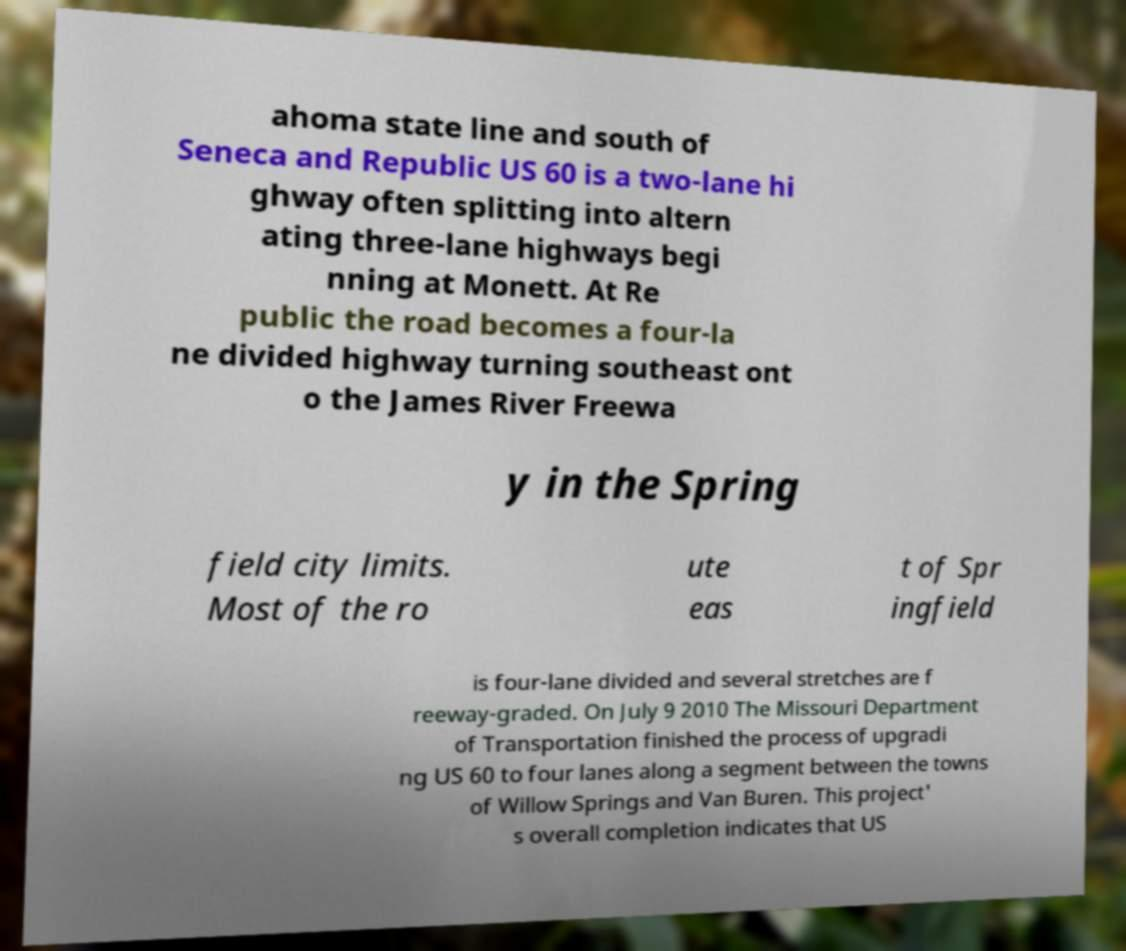There's text embedded in this image that I need extracted. Can you transcribe it verbatim? ahoma state line and south of Seneca and Republic US 60 is a two-lane hi ghway often splitting into altern ating three-lane highways begi nning at Monett. At Re public the road becomes a four-la ne divided highway turning southeast ont o the James River Freewa y in the Spring field city limits. Most of the ro ute eas t of Spr ingfield is four-lane divided and several stretches are f reeway-graded. On July 9 2010 The Missouri Department of Transportation finished the process of upgradi ng US 60 to four lanes along a segment between the towns of Willow Springs and Van Buren. This project' s overall completion indicates that US 